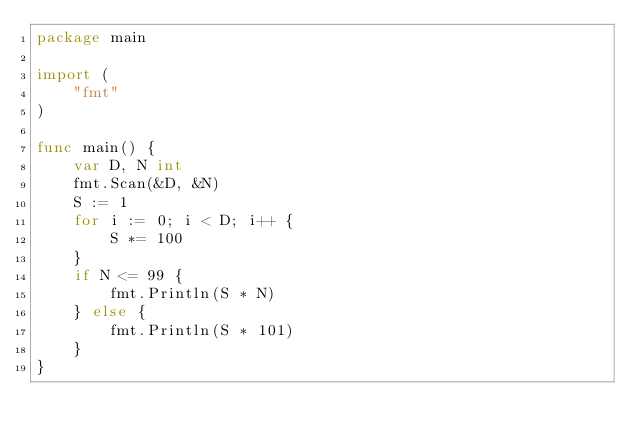Convert code to text. <code><loc_0><loc_0><loc_500><loc_500><_Go_>package main

import (
	"fmt"
)

func main() {
	var D, N int
	fmt.Scan(&D, &N)
	S := 1
	for i := 0; i < D; i++ {
		S *= 100
	}
	if N <= 99 {
		fmt.Println(S * N)
	} else {
		fmt.Println(S * 101)
	}
}</code> 